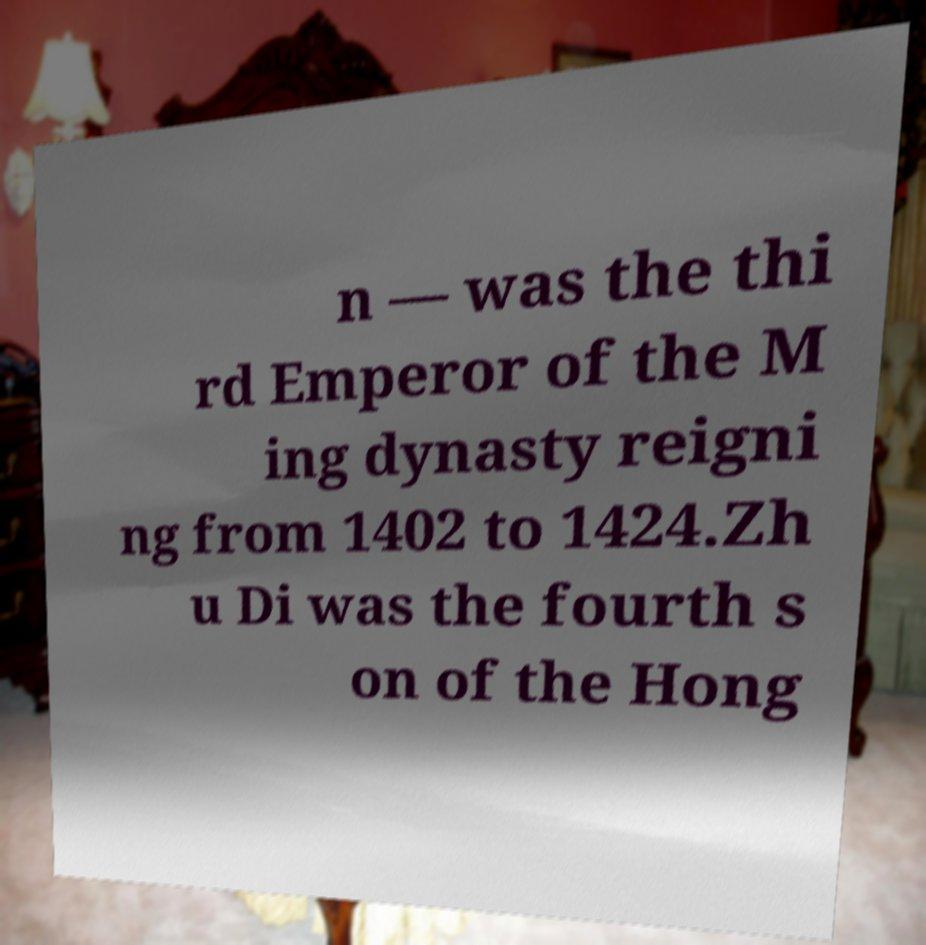There's text embedded in this image that I need extracted. Can you transcribe it verbatim? n — was the thi rd Emperor of the M ing dynasty reigni ng from 1402 to 1424.Zh u Di was the fourth s on of the Hong 